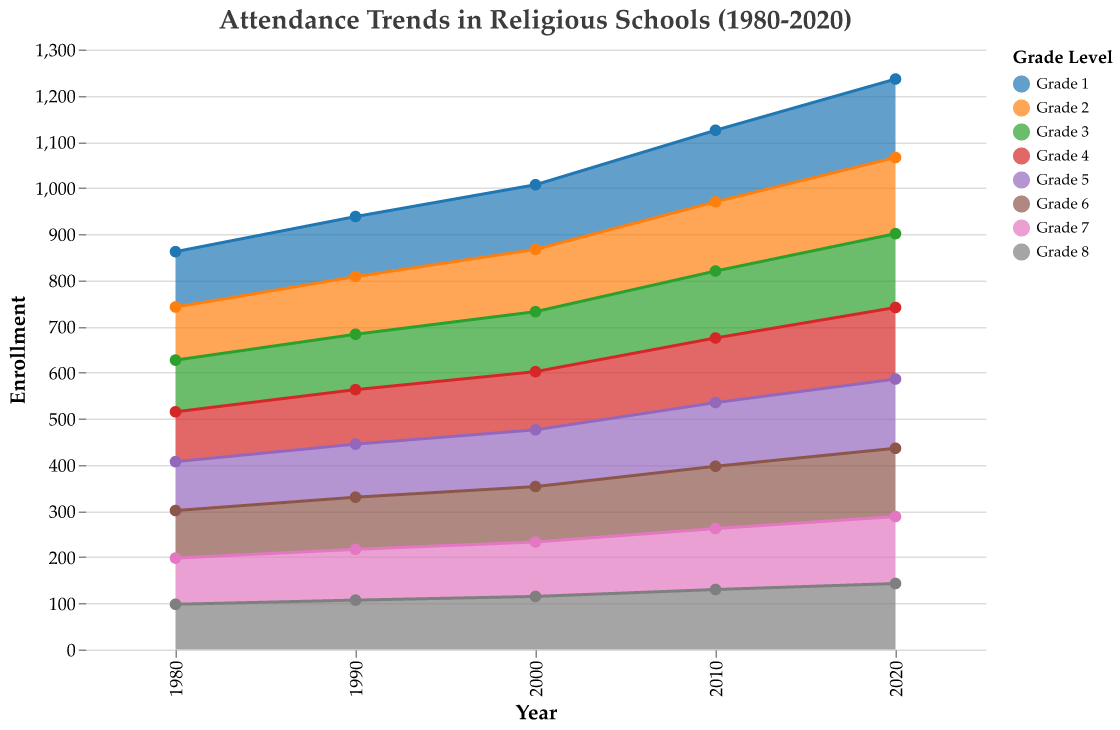What is the overall title of the area chart? The title is usually at the top of the chart in a noticeable font. In this case, it is "Attendance Trends in Religious Schools (1980-2020)."
Answer: Attendance Trends in Religious Schools (1980-2020) How is enrollment changing for Grade 1 from 1980 to 2020? By looking at the ends of the area representing Grade 1 from left to right, we can see that the height of the Grade 1 section increases from 120 in 1980 to 170 in 2020.
Answer: It is increasing Which year had the highest total enrollment across all grades? To find this, we need to visually compare the overall height of the stacked areas for each year. The year 2020 has the highest cumulative height across all grades.
Answer: 2020 What is the trend in Grade 8 enrollment from 1980 to 2020? We can follow the line of the area representing Grade 8 from left to right. Enrollment for Grade 8 starts at 98 in 1980 and ends at 143 in 2020.
Answer: Increasing Compare the enrollment in Grade 4 in 1990 to 2010. Which is higher? We look at the points corresponding to Grade 4 in 1990 and 2010. In 1990 it is 118, and in 2010 it is 140.
Answer: 2010 Which grade had the least increase in enrollment from 1980 to 2020? Subtract the enrollment values for each grade in 1980 from the corresponding values in 2020 and compare the differences. For example, Grade 7 increased from 100 to 145, which is an increase of 45. Grade 1 increased from 120 to 170, which is an increase of 50, and so forth. The grade with the least increase is Grade 8, increasing from 98 to 143, a difference of 45.
Answer: Grade 8 What does the color scheme represent in the chart? The colors differentiate the various grade levels. Each distinct color represents a specific grade from Grade 1 to Grade 8.
Answer: Grade level How does the enrollment in Grade 6 compare between 1980 and 1990? By comparing the enrollment values for Grade 6 in both years. In 1980, it is 103, and in 1990, it is 113.
Answer: 1990 is higher by 10 students What is the average enrollment for Grade 3 across all the years shown? Sum the enrollment figures for Grade 3 in each decade: 112 (1980), 120 (1990), 130 (2000), 145 (2010), and 160 (2020). The total sum is 667. Divide this by the number of decades (5) to get the average. 667 / 5 = 133.4
Answer: 133.4 Which year had the smallest total enrollment? By visually comparing the total height of the stacked areas, we see that 1980 has the smallest total enrollment across all grades.
Answer: 1980 